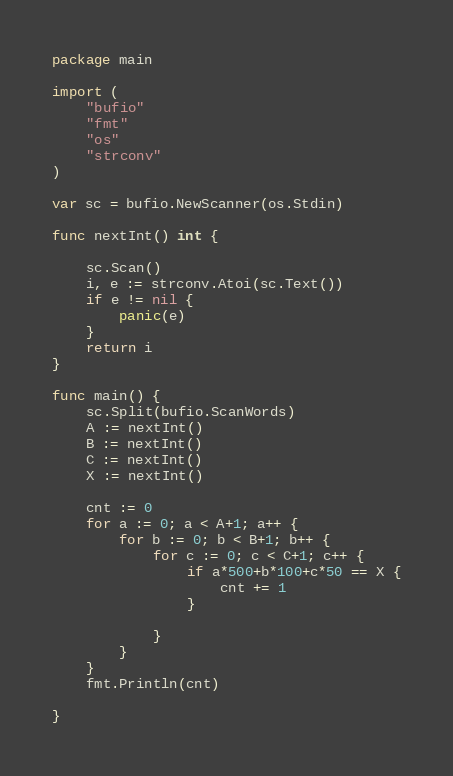Convert code to text. <code><loc_0><loc_0><loc_500><loc_500><_Go_>package main

import (
	"bufio"
	"fmt"
	"os"
	"strconv"
)

var sc = bufio.NewScanner(os.Stdin)

func nextInt() int {

	sc.Scan()
	i, e := strconv.Atoi(sc.Text())
	if e != nil {
		panic(e)
	}
	return i
}

func main() {
	sc.Split(bufio.ScanWords)
	A := nextInt()
	B := nextInt()
	C := nextInt()
	X := nextInt()

	cnt := 0
	for a := 0; a < A+1; a++ {
		for b := 0; b < B+1; b++ {
			for c := 0; c < C+1; c++ {
				if a*500+b*100+c*50 == X {
					cnt += 1
				}

			}
		}
	}
	fmt.Println(cnt)

}
</code> 